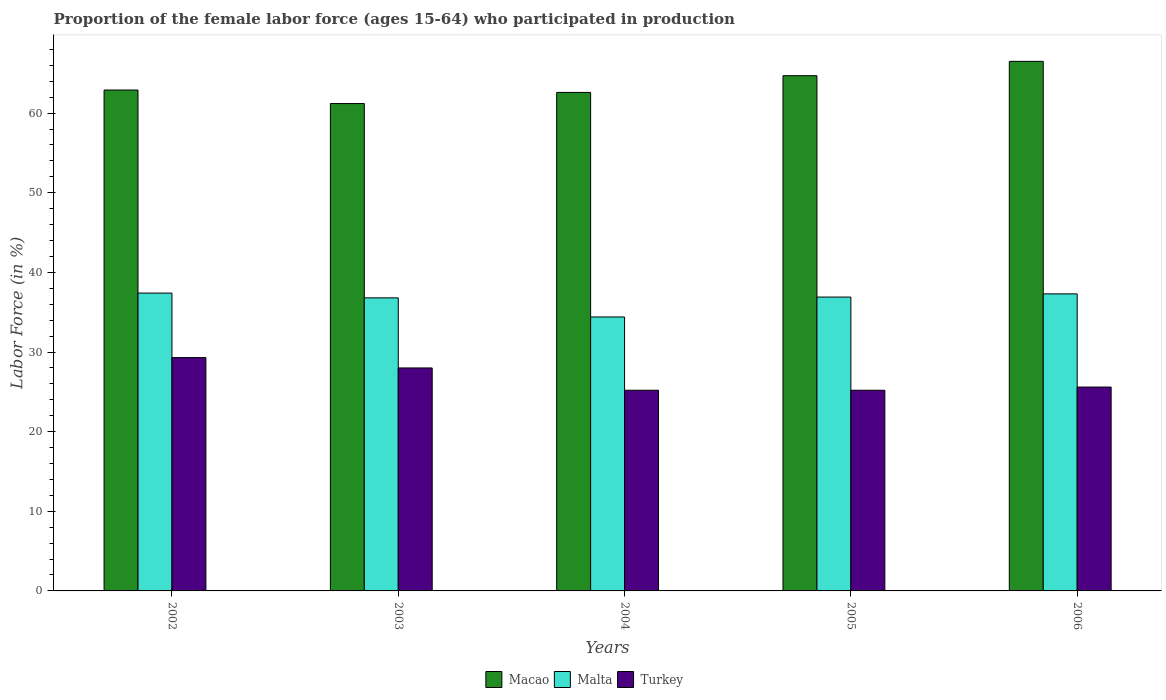How many groups of bars are there?
Keep it short and to the point. 5. Are the number of bars per tick equal to the number of legend labels?
Offer a very short reply. Yes. How many bars are there on the 4th tick from the right?
Offer a terse response. 3. What is the label of the 1st group of bars from the left?
Offer a terse response. 2002. What is the proportion of the female labor force who participated in production in Turkey in 2005?
Offer a terse response. 25.2. Across all years, what is the maximum proportion of the female labor force who participated in production in Malta?
Keep it short and to the point. 37.4. Across all years, what is the minimum proportion of the female labor force who participated in production in Malta?
Your response must be concise. 34.4. In which year was the proportion of the female labor force who participated in production in Macao maximum?
Your response must be concise. 2006. In which year was the proportion of the female labor force who participated in production in Malta minimum?
Your answer should be compact. 2004. What is the total proportion of the female labor force who participated in production in Malta in the graph?
Provide a succinct answer. 182.8. What is the difference between the proportion of the female labor force who participated in production in Turkey in 2003 and that in 2006?
Provide a succinct answer. 2.4. What is the difference between the proportion of the female labor force who participated in production in Malta in 2003 and the proportion of the female labor force who participated in production in Macao in 2004?
Provide a succinct answer. -25.8. What is the average proportion of the female labor force who participated in production in Turkey per year?
Keep it short and to the point. 26.66. In the year 2004, what is the difference between the proportion of the female labor force who participated in production in Macao and proportion of the female labor force who participated in production in Turkey?
Your answer should be compact. 37.4. What is the ratio of the proportion of the female labor force who participated in production in Turkey in 2002 to that in 2003?
Your answer should be compact. 1.05. Is the proportion of the female labor force who participated in production in Turkey in 2004 less than that in 2005?
Offer a terse response. No. What is the difference between the highest and the second highest proportion of the female labor force who participated in production in Turkey?
Offer a very short reply. 1.3. What is the difference between the highest and the lowest proportion of the female labor force who participated in production in Turkey?
Offer a terse response. 4.1. In how many years, is the proportion of the female labor force who participated in production in Turkey greater than the average proportion of the female labor force who participated in production in Turkey taken over all years?
Ensure brevity in your answer.  2. Is the sum of the proportion of the female labor force who participated in production in Malta in 2003 and 2004 greater than the maximum proportion of the female labor force who participated in production in Turkey across all years?
Provide a succinct answer. Yes. What does the 2nd bar from the left in 2004 represents?
Give a very brief answer. Malta. What does the 2nd bar from the right in 2004 represents?
Keep it short and to the point. Malta. Is it the case that in every year, the sum of the proportion of the female labor force who participated in production in Macao and proportion of the female labor force who participated in production in Turkey is greater than the proportion of the female labor force who participated in production in Malta?
Provide a short and direct response. Yes. Are all the bars in the graph horizontal?
Your answer should be compact. No. Are the values on the major ticks of Y-axis written in scientific E-notation?
Offer a terse response. No. How many legend labels are there?
Make the answer very short. 3. How are the legend labels stacked?
Provide a short and direct response. Horizontal. What is the title of the graph?
Provide a succinct answer. Proportion of the female labor force (ages 15-64) who participated in production. What is the label or title of the X-axis?
Provide a succinct answer. Years. What is the Labor Force (in %) in Macao in 2002?
Provide a short and direct response. 62.9. What is the Labor Force (in %) in Malta in 2002?
Ensure brevity in your answer.  37.4. What is the Labor Force (in %) of Turkey in 2002?
Your answer should be very brief. 29.3. What is the Labor Force (in %) in Macao in 2003?
Offer a very short reply. 61.2. What is the Labor Force (in %) of Malta in 2003?
Your response must be concise. 36.8. What is the Labor Force (in %) of Macao in 2004?
Provide a short and direct response. 62.6. What is the Labor Force (in %) in Malta in 2004?
Offer a very short reply. 34.4. What is the Labor Force (in %) of Turkey in 2004?
Your response must be concise. 25.2. What is the Labor Force (in %) of Macao in 2005?
Provide a short and direct response. 64.7. What is the Labor Force (in %) in Malta in 2005?
Offer a terse response. 36.9. What is the Labor Force (in %) of Turkey in 2005?
Offer a very short reply. 25.2. What is the Labor Force (in %) in Macao in 2006?
Give a very brief answer. 66.5. What is the Labor Force (in %) in Malta in 2006?
Provide a short and direct response. 37.3. What is the Labor Force (in %) in Turkey in 2006?
Provide a short and direct response. 25.6. Across all years, what is the maximum Labor Force (in %) of Macao?
Your response must be concise. 66.5. Across all years, what is the maximum Labor Force (in %) of Malta?
Your answer should be very brief. 37.4. Across all years, what is the maximum Labor Force (in %) of Turkey?
Offer a terse response. 29.3. Across all years, what is the minimum Labor Force (in %) of Macao?
Offer a very short reply. 61.2. Across all years, what is the minimum Labor Force (in %) of Malta?
Make the answer very short. 34.4. Across all years, what is the minimum Labor Force (in %) of Turkey?
Provide a succinct answer. 25.2. What is the total Labor Force (in %) of Macao in the graph?
Keep it short and to the point. 317.9. What is the total Labor Force (in %) in Malta in the graph?
Provide a succinct answer. 182.8. What is the total Labor Force (in %) of Turkey in the graph?
Keep it short and to the point. 133.3. What is the difference between the Labor Force (in %) of Malta in 2002 and that in 2003?
Ensure brevity in your answer.  0.6. What is the difference between the Labor Force (in %) of Macao in 2002 and that in 2004?
Your response must be concise. 0.3. What is the difference between the Labor Force (in %) of Malta in 2002 and that in 2005?
Provide a short and direct response. 0.5. What is the difference between the Labor Force (in %) in Turkey in 2002 and that in 2005?
Keep it short and to the point. 4.1. What is the difference between the Labor Force (in %) of Malta in 2002 and that in 2006?
Offer a very short reply. 0.1. What is the difference between the Labor Force (in %) of Macao in 2003 and that in 2004?
Give a very brief answer. -1.4. What is the difference between the Labor Force (in %) in Malta in 2003 and that in 2004?
Give a very brief answer. 2.4. What is the difference between the Labor Force (in %) of Turkey in 2003 and that in 2004?
Your answer should be compact. 2.8. What is the difference between the Labor Force (in %) of Macao in 2003 and that in 2005?
Provide a succinct answer. -3.5. What is the difference between the Labor Force (in %) in Malta in 2003 and that in 2005?
Your answer should be very brief. -0.1. What is the difference between the Labor Force (in %) in Macao in 2003 and that in 2006?
Your answer should be compact. -5.3. What is the difference between the Labor Force (in %) of Malta in 2003 and that in 2006?
Provide a succinct answer. -0.5. What is the difference between the Labor Force (in %) of Turkey in 2003 and that in 2006?
Provide a short and direct response. 2.4. What is the difference between the Labor Force (in %) of Turkey in 2004 and that in 2005?
Your answer should be very brief. 0. What is the difference between the Labor Force (in %) in Macao in 2004 and that in 2006?
Keep it short and to the point. -3.9. What is the difference between the Labor Force (in %) in Malta in 2004 and that in 2006?
Provide a short and direct response. -2.9. What is the difference between the Labor Force (in %) in Turkey in 2004 and that in 2006?
Your answer should be very brief. -0.4. What is the difference between the Labor Force (in %) of Macao in 2005 and that in 2006?
Keep it short and to the point. -1.8. What is the difference between the Labor Force (in %) of Macao in 2002 and the Labor Force (in %) of Malta in 2003?
Your response must be concise. 26.1. What is the difference between the Labor Force (in %) of Macao in 2002 and the Labor Force (in %) of Turkey in 2003?
Make the answer very short. 34.9. What is the difference between the Labor Force (in %) in Malta in 2002 and the Labor Force (in %) in Turkey in 2003?
Keep it short and to the point. 9.4. What is the difference between the Labor Force (in %) of Macao in 2002 and the Labor Force (in %) of Malta in 2004?
Your response must be concise. 28.5. What is the difference between the Labor Force (in %) in Macao in 2002 and the Labor Force (in %) in Turkey in 2004?
Offer a terse response. 37.7. What is the difference between the Labor Force (in %) of Malta in 2002 and the Labor Force (in %) of Turkey in 2004?
Your answer should be very brief. 12.2. What is the difference between the Labor Force (in %) of Macao in 2002 and the Labor Force (in %) of Turkey in 2005?
Your answer should be compact. 37.7. What is the difference between the Labor Force (in %) of Malta in 2002 and the Labor Force (in %) of Turkey in 2005?
Keep it short and to the point. 12.2. What is the difference between the Labor Force (in %) of Macao in 2002 and the Labor Force (in %) of Malta in 2006?
Offer a very short reply. 25.6. What is the difference between the Labor Force (in %) in Macao in 2002 and the Labor Force (in %) in Turkey in 2006?
Provide a succinct answer. 37.3. What is the difference between the Labor Force (in %) in Malta in 2002 and the Labor Force (in %) in Turkey in 2006?
Make the answer very short. 11.8. What is the difference between the Labor Force (in %) in Macao in 2003 and the Labor Force (in %) in Malta in 2004?
Make the answer very short. 26.8. What is the difference between the Labor Force (in %) of Macao in 2003 and the Labor Force (in %) of Malta in 2005?
Provide a succinct answer. 24.3. What is the difference between the Labor Force (in %) in Malta in 2003 and the Labor Force (in %) in Turkey in 2005?
Your answer should be very brief. 11.6. What is the difference between the Labor Force (in %) in Macao in 2003 and the Labor Force (in %) in Malta in 2006?
Ensure brevity in your answer.  23.9. What is the difference between the Labor Force (in %) of Macao in 2003 and the Labor Force (in %) of Turkey in 2006?
Make the answer very short. 35.6. What is the difference between the Labor Force (in %) in Macao in 2004 and the Labor Force (in %) in Malta in 2005?
Offer a very short reply. 25.7. What is the difference between the Labor Force (in %) in Macao in 2004 and the Labor Force (in %) in Turkey in 2005?
Your answer should be compact. 37.4. What is the difference between the Labor Force (in %) of Macao in 2004 and the Labor Force (in %) of Malta in 2006?
Ensure brevity in your answer.  25.3. What is the difference between the Labor Force (in %) of Macao in 2004 and the Labor Force (in %) of Turkey in 2006?
Keep it short and to the point. 37. What is the difference between the Labor Force (in %) of Malta in 2004 and the Labor Force (in %) of Turkey in 2006?
Your response must be concise. 8.8. What is the difference between the Labor Force (in %) of Macao in 2005 and the Labor Force (in %) of Malta in 2006?
Provide a short and direct response. 27.4. What is the difference between the Labor Force (in %) of Macao in 2005 and the Labor Force (in %) of Turkey in 2006?
Provide a short and direct response. 39.1. What is the average Labor Force (in %) of Macao per year?
Your response must be concise. 63.58. What is the average Labor Force (in %) of Malta per year?
Offer a very short reply. 36.56. What is the average Labor Force (in %) in Turkey per year?
Your answer should be compact. 26.66. In the year 2002, what is the difference between the Labor Force (in %) in Macao and Labor Force (in %) in Turkey?
Provide a short and direct response. 33.6. In the year 2003, what is the difference between the Labor Force (in %) in Macao and Labor Force (in %) in Malta?
Make the answer very short. 24.4. In the year 2003, what is the difference between the Labor Force (in %) in Macao and Labor Force (in %) in Turkey?
Your response must be concise. 33.2. In the year 2004, what is the difference between the Labor Force (in %) of Macao and Labor Force (in %) of Malta?
Offer a terse response. 28.2. In the year 2004, what is the difference between the Labor Force (in %) of Macao and Labor Force (in %) of Turkey?
Give a very brief answer. 37.4. In the year 2005, what is the difference between the Labor Force (in %) in Macao and Labor Force (in %) in Malta?
Your answer should be compact. 27.8. In the year 2005, what is the difference between the Labor Force (in %) in Macao and Labor Force (in %) in Turkey?
Make the answer very short. 39.5. In the year 2006, what is the difference between the Labor Force (in %) in Macao and Labor Force (in %) in Malta?
Keep it short and to the point. 29.2. In the year 2006, what is the difference between the Labor Force (in %) in Macao and Labor Force (in %) in Turkey?
Your answer should be compact. 40.9. In the year 2006, what is the difference between the Labor Force (in %) of Malta and Labor Force (in %) of Turkey?
Your answer should be compact. 11.7. What is the ratio of the Labor Force (in %) of Macao in 2002 to that in 2003?
Make the answer very short. 1.03. What is the ratio of the Labor Force (in %) of Malta in 2002 to that in 2003?
Your answer should be very brief. 1.02. What is the ratio of the Labor Force (in %) in Turkey in 2002 to that in 2003?
Provide a succinct answer. 1.05. What is the ratio of the Labor Force (in %) of Macao in 2002 to that in 2004?
Give a very brief answer. 1. What is the ratio of the Labor Force (in %) in Malta in 2002 to that in 2004?
Provide a short and direct response. 1.09. What is the ratio of the Labor Force (in %) in Turkey in 2002 to that in 2004?
Your answer should be very brief. 1.16. What is the ratio of the Labor Force (in %) of Macao in 2002 to that in 2005?
Make the answer very short. 0.97. What is the ratio of the Labor Force (in %) in Malta in 2002 to that in 2005?
Ensure brevity in your answer.  1.01. What is the ratio of the Labor Force (in %) of Turkey in 2002 to that in 2005?
Give a very brief answer. 1.16. What is the ratio of the Labor Force (in %) of Macao in 2002 to that in 2006?
Make the answer very short. 0.95. What is the ratio of the Labor Force (in %) in Malta in 2002 to that in 2006?
Give a very brief answer. 1. What is the ratio of the Labor Force (in %) in Turkey in 2002 to that in 2006?
Offer a very short reply. 1.14. What is the ratio of the Labor Force (in %) in Macao in 2003 to that in 2004?
Your answer should be very brief. 0.98. What is the ratio of the Labor Force (in %) of Malta in 2003 to that in 2004?
Give a very brief answer. 1.07. What is the ratio of the Labor Force (in %) of Turkey in 2003 to that in 2004?
Offer a terse response. 1.11. What is the ratio of the Labor Force (in %) in Macao in 2003 to that in 2005?
Your answer should be compact. 0.95. What is the ratio of the Labor Force (in %) of Malta in 2003 to that in 2005?
Offer a terse response. 1. What is the ratio of the Labor Force (in %) in Turkey in 2003 to that in 2005?
Provide a short and direct response. 1.11. What is the ratio of the Labor Force (in %) of Macao in 2003 to that in 2006?
Offer a very short reply. 0.92. What is the ratio of the Labor Force (in %) of Malta in 2003 to that in 2006?
Your answer should be compact. 0.99. What is the ratio of the Labor Force (in %) in Turkey in 2003 to that in 2006?
Provide a succinct answer. 1.09. What is the ratio of the Labor Force (in %) in Macao in 2004 to that in 2005?
Your answer should be compact. 0.97. What is the ratio of the Labor Force (in %) in Malta in 2004 to that in 2005?
Provide a short and direct response. 0.93. What is the ratio of the Labor Force (in %) of Macao in 2004 to that in 2006?
Make the answer very short. 0.94. What is the ratio of the Labor Force (in %) in Malta in 2004 to that in 2006?
Make the answer very short. 0.92. What is the ratio of the Labor Force (in %) in Turkey in 2004 to that in 2006?
Provide a succinct answer. 0.98. What is the ratio of the Labor Force (in %) of Macao in 2005 to that in 2006?
Provide a succinct answer. 0.97. What is the ratio of the Labor Force (in %) of Malta in 2005 to that in 2006?
Provide a short and direct response. 0.99. What is the ratio of the Labor Force (in %) in Turkey in 2005 to that in 2006?
Give a very brief answer. 0.98. What is the difference between the highest and the lowest Labor Force (in %) in Turkey?
Keep it short and to the point. 4.1. 